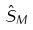<formula> <loc_0><loc_0><loc_500><loc_500>\hat { S } _ { M }</formula> 